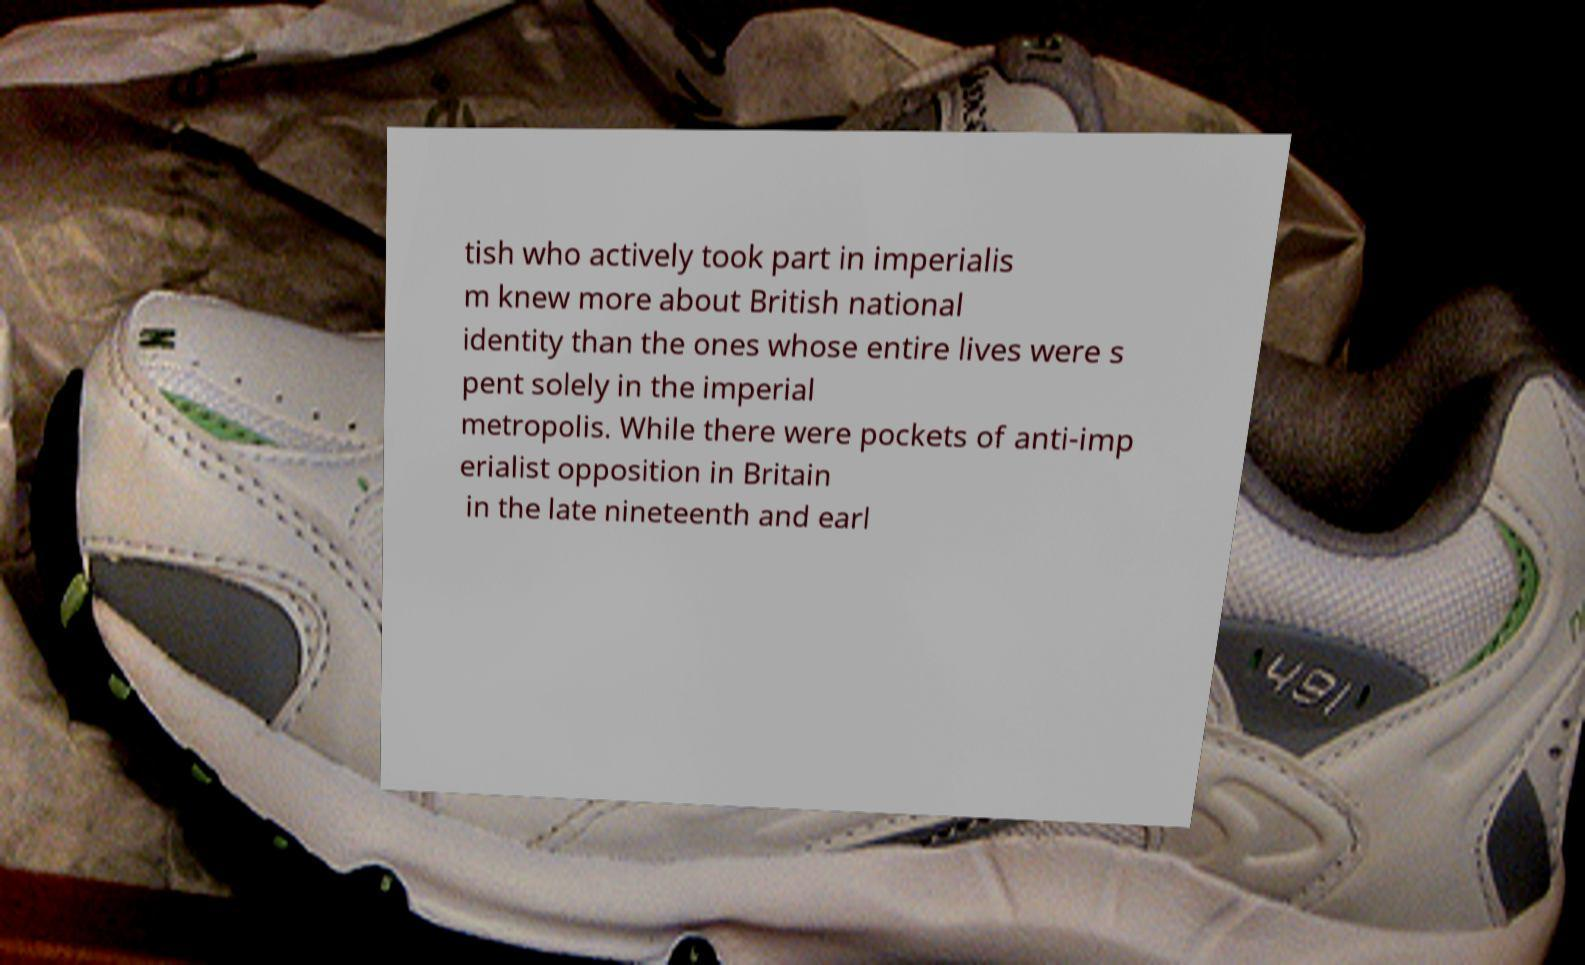Could you extract and type out the text from this image? tish who actively took part in imperialis m knew more about British national identity than the ones whose entire lives were s pent solely in the imperial metropolis. While there were pockets of anti-imp erialist opposition in Britain in the late nineteenth and earl 